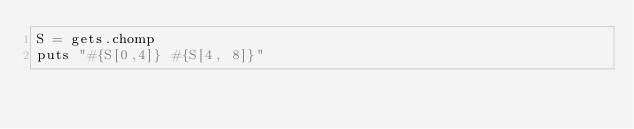<code> <loc_0><loc_0><loc_500><loc_500><_Ruby_>S = gets.chomp
puts "#{S[0,4]} #{S[4, 8]}"</code> 